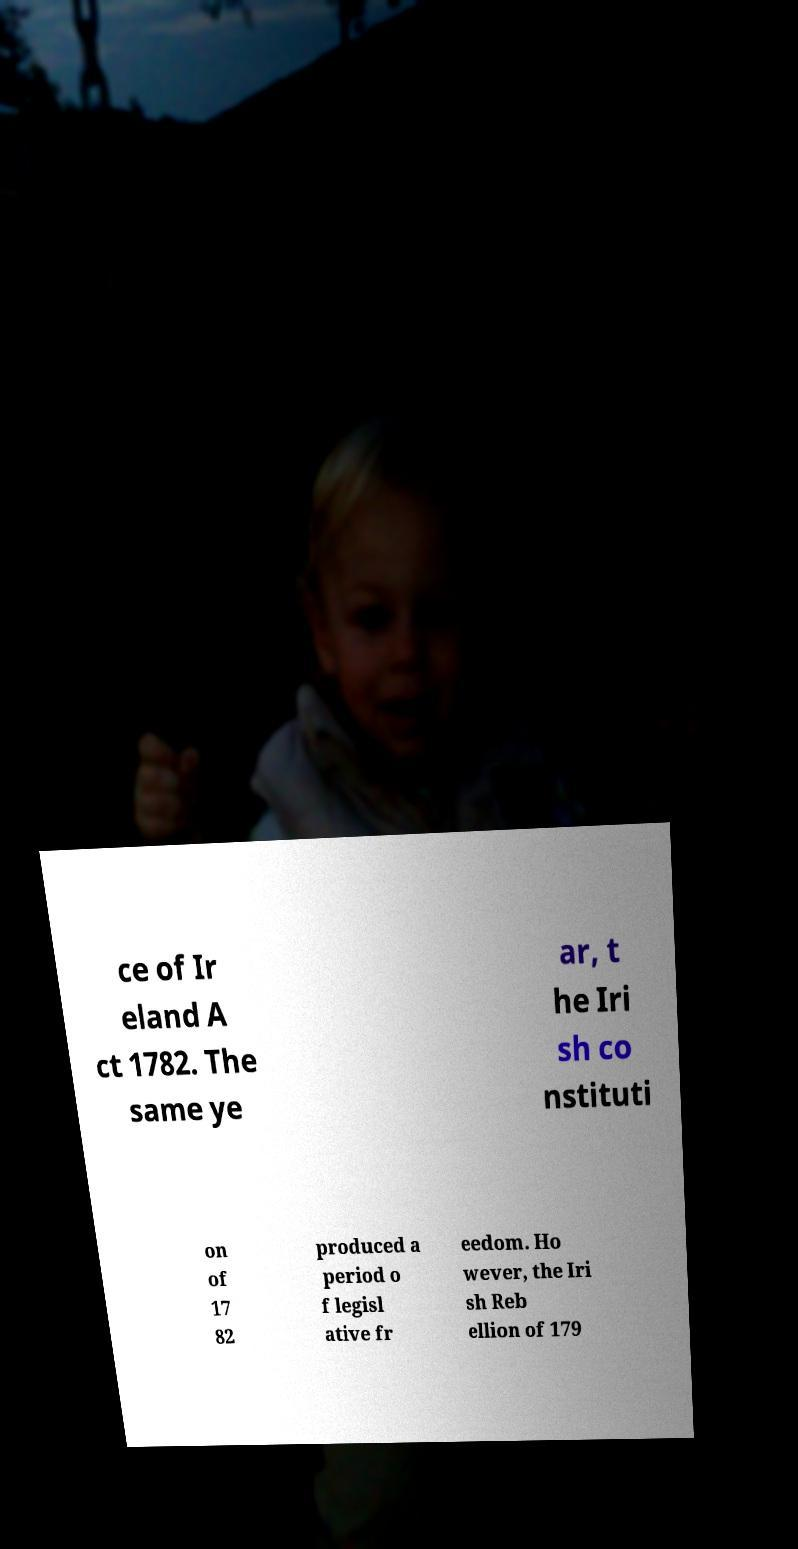There's text embedded in this image that I need extracted. Can you transcribe it verbatim? ce of Ir eland A ct 1782. The same ye ar, t he Iri sh co nstituti on of 17 82 produced a period o f legisl ative fr eedom. Ho wever, the Iri sh Reb ellion of 179 